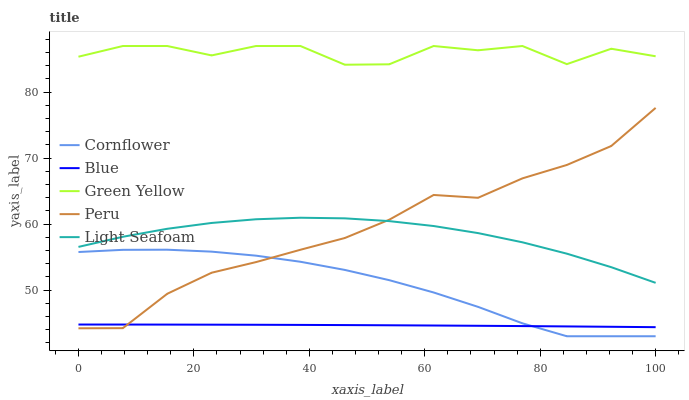Does Blue have the minimum area under the curve?
Answer yes or no. Yes. Does Green Yellow have the maximum area under the curve?
Answer yes or no. Yes. Does Cornflower have the minimum area under the curve?
Answer yes or no. No. Does Cornflower have the maximum area under the curve?
Answer yes or no. No. Is Blue the smoothest?
Answer yes or no. Yes. Is Green Yellow the roughest?
Answer yes or no. Yes. Is Cornflower the smoothest?
Answer yes or no. No. Is Cornflower the roughest?
Answer yes or no. No. Does Green Yellow have the lowest value?
Answer yes or no. No. Does Cornflower have the highest value?
Answer yes or no. No. Is Peru less than Green Yellow?
Answer yes or no. Yes. Is Light Seafoam greater than Cornflower?
Answer yes or no. Yes. Does Peru intersect Green Yellow?
Answer yes or no. No. 